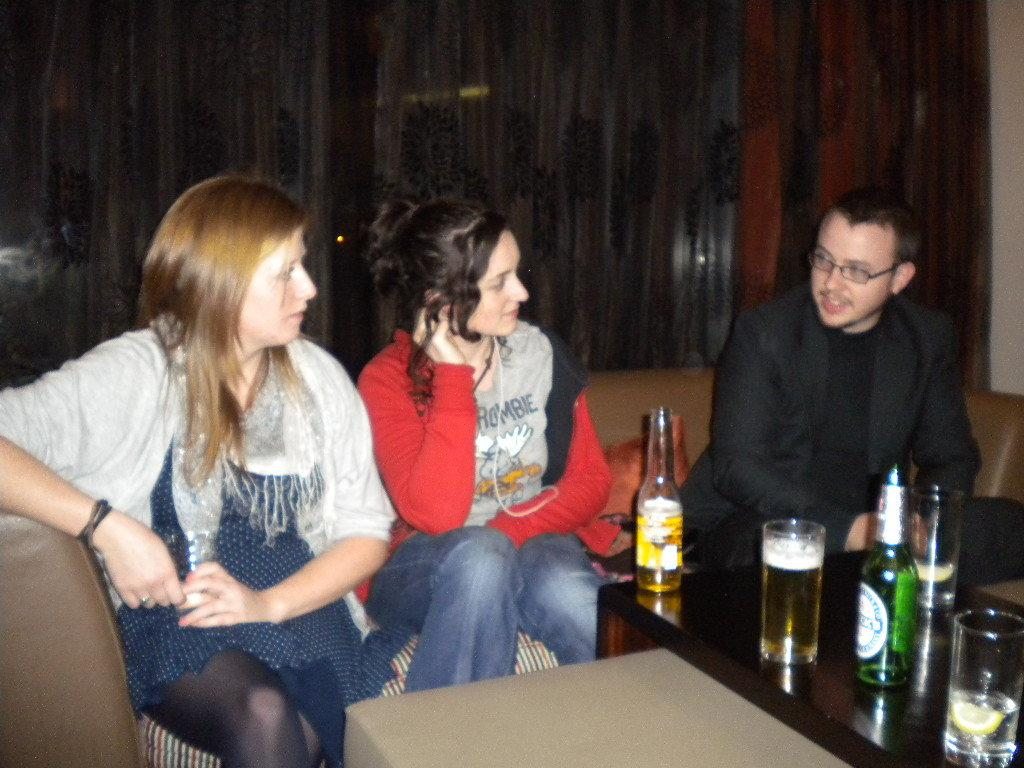How many people are in the image? There are three individuals in the image, two women and a man. What are the people in the image doing? The three individuals are sitting on a sofa. What can be seen on the table in the image? There are two beer bottles and three glasses on the table. What is the process of the sofa rolling in the image? The sofa does not roll in the image; it is stationary, and the individuals are sitting on it. 